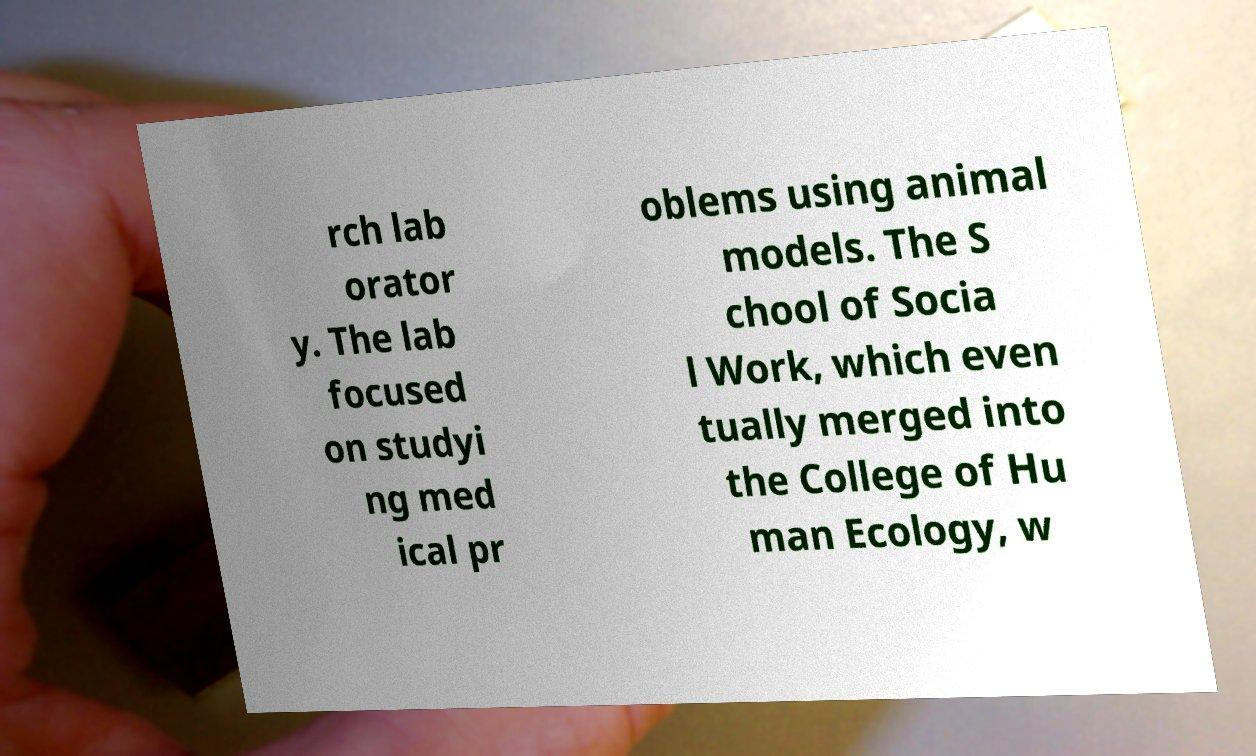Can you accurately transcribe the text from the provided image for me? rch lab orator y. The lab focused on studyi ng med ical pr oblems using animal models. The S chool of Socia l Work, which even tually merged into the College of Hu man Ecology, w 